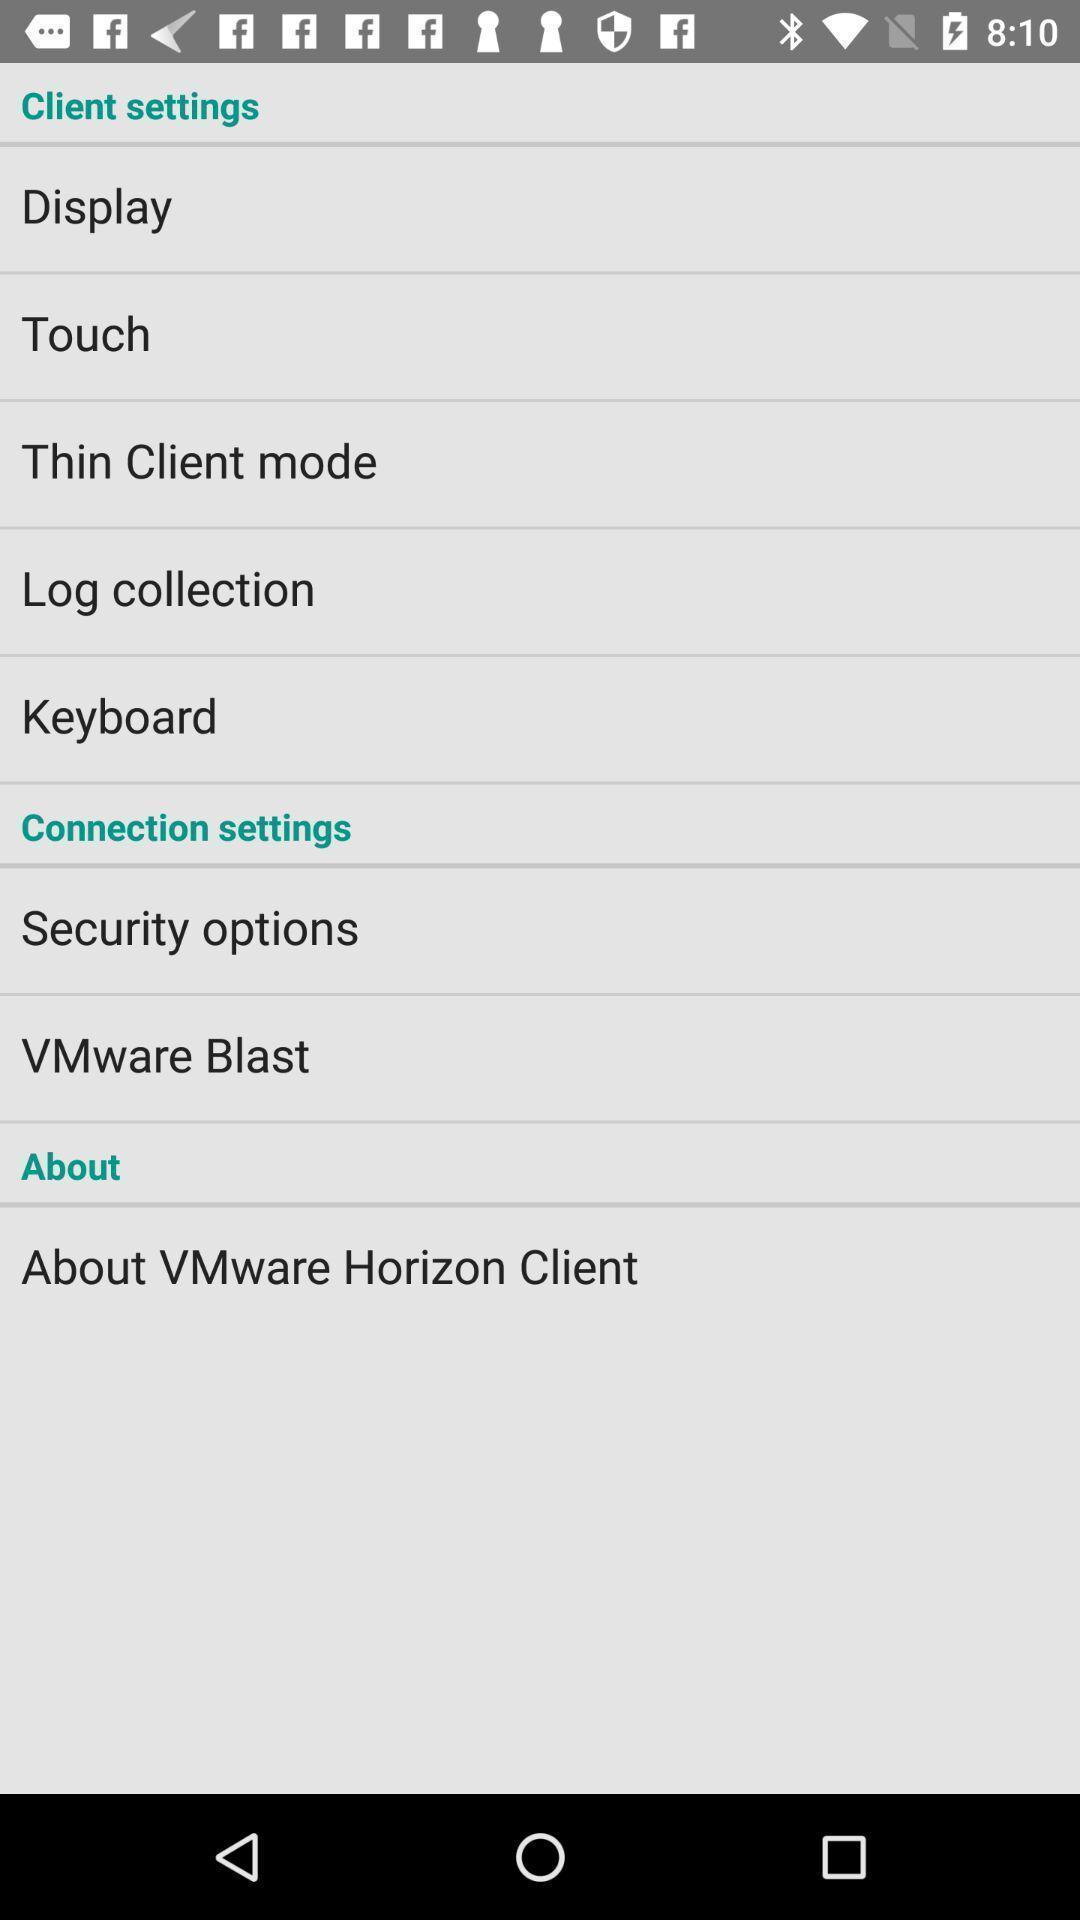Tell me about the visual elements in this screen capture. Settings page of a virtual desktop application. 